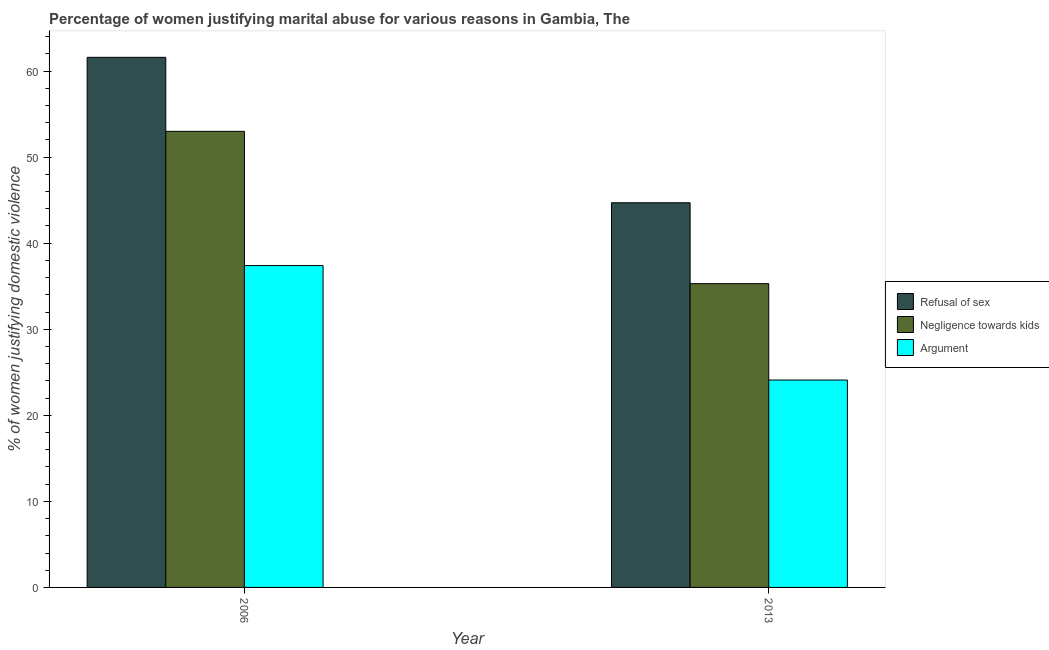Are the number of bars per tick equal to the number of legend labels?
Ensure brevity in your answer.  Yes. How many bars are there on the 2nd tick from the left?
Offer a very short reply. 3. In how many cases, is the number of bars for a given year not equal to the number of legend labels?
Make the answer very short. 0. Across all years, what is the maximum percentage of women justifying domestic violence due to refusal of sex?
Your answer should be compact. 61.6. Across all years, what is the minimum percentage of women justifying domestic violence due to refusal of sex?
Your response must be concise. 44.7. What is the total percentage of women justifying domestic violence due to refusal of sex in the graph?
Offer a terse response. 106.3. What is the difference between the percentage of women justifying domestic violence due to negligence towards kids in 2006 and that in 2013?
Ensure brevity in your answer.  17.7. What is the difference between the percentage of women justifying domestic violence due to negligence towards kids in 2013 and the percentage of women justifying domestic violence due to refusal of sex in 2006?
Ensure brevity in your answer.  -17.7. What is the average percentage of women justifying domestic violence due to negligence towards kids per year?
Give a very brief answer. 44.15. In how many years, is the percentage of women justifying domestic violence due to refusal of sex greater than 26 %?
Make the answer very short. 2. What is the ratio of the percentage of women justifying domestic violence due to negligence towards kids in 2006 to that in 2013?
Your response must be concise. 1.5. What does the 1st bar from the left in 2013 represents?
Make the answer very short. Refusal of sex. What does the 3rd bar from the right in 2006 represents?
Provide a succinct answer. Refusal of sex. Is it the case that in every year, the sum of the percentage of women justifying domestic violence due to refusal of sex and percentage of women justifying domestic violence due to negligence towards kids is greater than the percentage of women justifying domestic violence due to arguments?
Your answer should be compact. Yes. How many bars are there?
Give a very brief answer. 6. How many years are there in the graph?
Provide a short and direct response. 2. Are the values on the major ticks of Y-axis written in scientific E-notation?
Make the answer very short. No. Where does the legend appear in the graph?
Ensure brevity in your answer.  Center right. How many legend labels are there?
Ensure brevity in your answer.  3. What is the title of the graph?
Your response must be concise. Percentage of women justifying marital abuse for various reasons in Gambia, The. What is the label or title of the X-axis?
Your answer should be compact. Year. What is the label or title of the Y-axis?
Your answer should be very brief. % of women justifying domestic violence. What is the % of women justifying domestic violence in Refusal of sex in 2006?
Provide a succinct answer. 61.6. What is the % of women justifying domestic violence in Argument in 2006?
Give a very brief answer. 37.4. What is the % of women justifying domestic violence in Refusal of sex in 2013?
Offer a terse response. 44.7. What is the % of women justifying domestic violence of Negligence towards kids in 2013?
Your response must be concise. 35.3. What is the % of women justifying domestic violence of Argument in 2013?
Offer a terse response. 24.1. Across all years, what is the maximum % of women justifying domestic violence in Refusal of sex?
Offer a terse response. 61.6. Across all years, what is the maximum % of women justifying domestic violence in Negligence towards kids?
Your answer should be very brief. 53. Across all years, what is the maximum % of women justifying domestic violence of Argument?
Provide a short and direct response. 37.4. Across all years, what is the minimum % of women justifying domestic violence in Refusal of sex?
Make the answer very short. 44.7. Across all years, what is the minimum % of women justifying domestic violence of Negligence towards kids?
Provide a succinct answer. 35.3. Across all years, what is the minimum % of women justifying domestic violence in Argument?
Provide a short and direct response. 24.1. What is the total % of women justifying domestic violence of Refusal of sex in the graph?
Your answer should be compact. 106.3. What is the total % of women justifying domestic violence in Negligence towards kids in the graph?
Provide a short and direct response. 88.3. What is the total % of women justifying domestic violence of Argument in the graph?
Offer a terse response. 61.5. What is the difference between the % of women justifying domestic violence in Negligence towards kids in 2006 and that in 2013?
Offer a very short reply. 17.7. What is the difference between the % of women justifying domestic violence of Argument in 2006 and that in 2013?
Your response must be concise. 13.3. What is the difference between the % of women justifying domestic violence of Refusal of sex in 2006 and the % of women justifying domestic violence of Negligence towards kids in 2013?
Make the answer very short. 26.3. What is the difference between the % of women justifying domestic violence of Refusal of sex in 2006 and the % of women justifying domestic violence of Argument in 2013?
Your answer should be compact. 37.5. What is the difference between the % of women justifying domestic violence in Negligence towards kids in 2006 and the % of women justifying domestic violence in Argument in 2013?
Your answer should be very brief. 28.9. What is the average % of women justifying domestic violence in Refusal of sex per year?
Your answer should be very brief. 53.15. What is the average % of women justifying domestic violence of Negligence towards kids per year?
Provide a succinct answer. 44.15. What is the average % of women justifying domestic violence in Argument per year?
Provide a succinct answer. 30.75. In the year 2006, what is the difference between the % of women justifying domestic violence in Refusal of sex and % of women justifying domestic violence in Argument?
Your answer should be compact. 24.2. In the year 2013, what is the difference between the % of women justifying domestic violence of Refusal of sex and % of women justifying domestic violence of Negligence towards kids?
Ensure brevity in your answer.  9.4. In the year 2013, what is the difference between the % of women justifying domestic violence of Refusal of sex and % of women justifying domestic violence of Argument?
Make the answer very short. 20.6. What is the ratio of the % of women justifying domestic violence of Refusal of sex in 2006 to that in 2013?
Your answer should be very brief. 1.38. What is the ratio of the % of women justifying domestic violence of Negligence towards kids in 2006 to that in 2013?
Offer a terse response. 1.5. What is the ratio of the % of women justifying domestic violence of Argument in 2006 to that in 2013?
Offer a terse response. 1.55. What is the difference between the highest and the second highest % of women justifying domestic violence in Refusal of sex?
Provide a short and direct response. 16.9. What is the difference between the highest and the second highest % of women justifying domestic violence of Negligence towards kids?
Offer a terse response. 17.7. What is the difference between the highest and the lowest % of women justifying domestic violence of Negligence towards kids?
Your answer should be very brief. 17.7. What is the difference between the highest and the lowest % of women justifying domestic violence of Argument?
Offer a terse response. 13.3. 